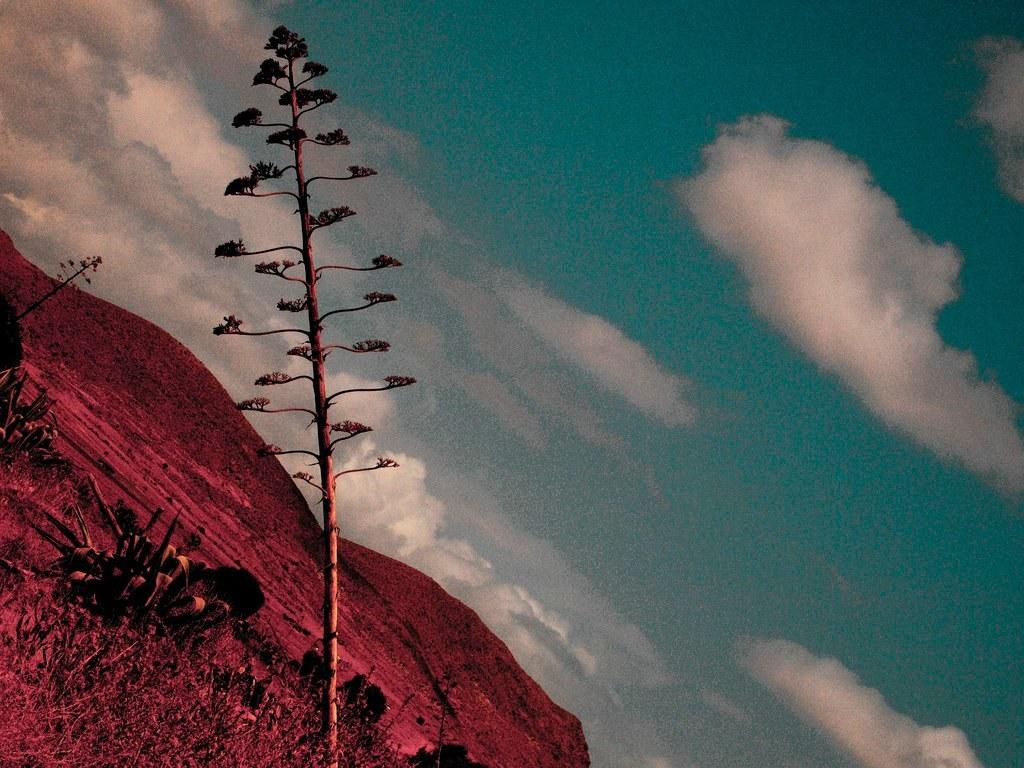What type of vegetation can be seen in the image? There are plants and grass in the image. What type of natural landform is visible in the image? There are mountains in the image. What is visible in the background of the image? The sky is visible in the background of the image. What can be seen in the sky in the image? Clouds are present in the sky. Reasoning: Let' Let's think step by step in order to produce the conversation. We start by identifying the main subjects in the image, which are the plants and grass. Then, we expand the conversation to include other natural elements, such as the mountains and the sky. Finally, we describe the specific features of the sky, which include the presence of clouds. Absurd Question/Answer: Can you tell me what book the chicken is reading in the image? There is no book or chicken present in the image. What type of conversation is happening between the plants in the image? Plants do not have the ability to talk or engage in conversation, so there is no conversation happening between them in the image. 